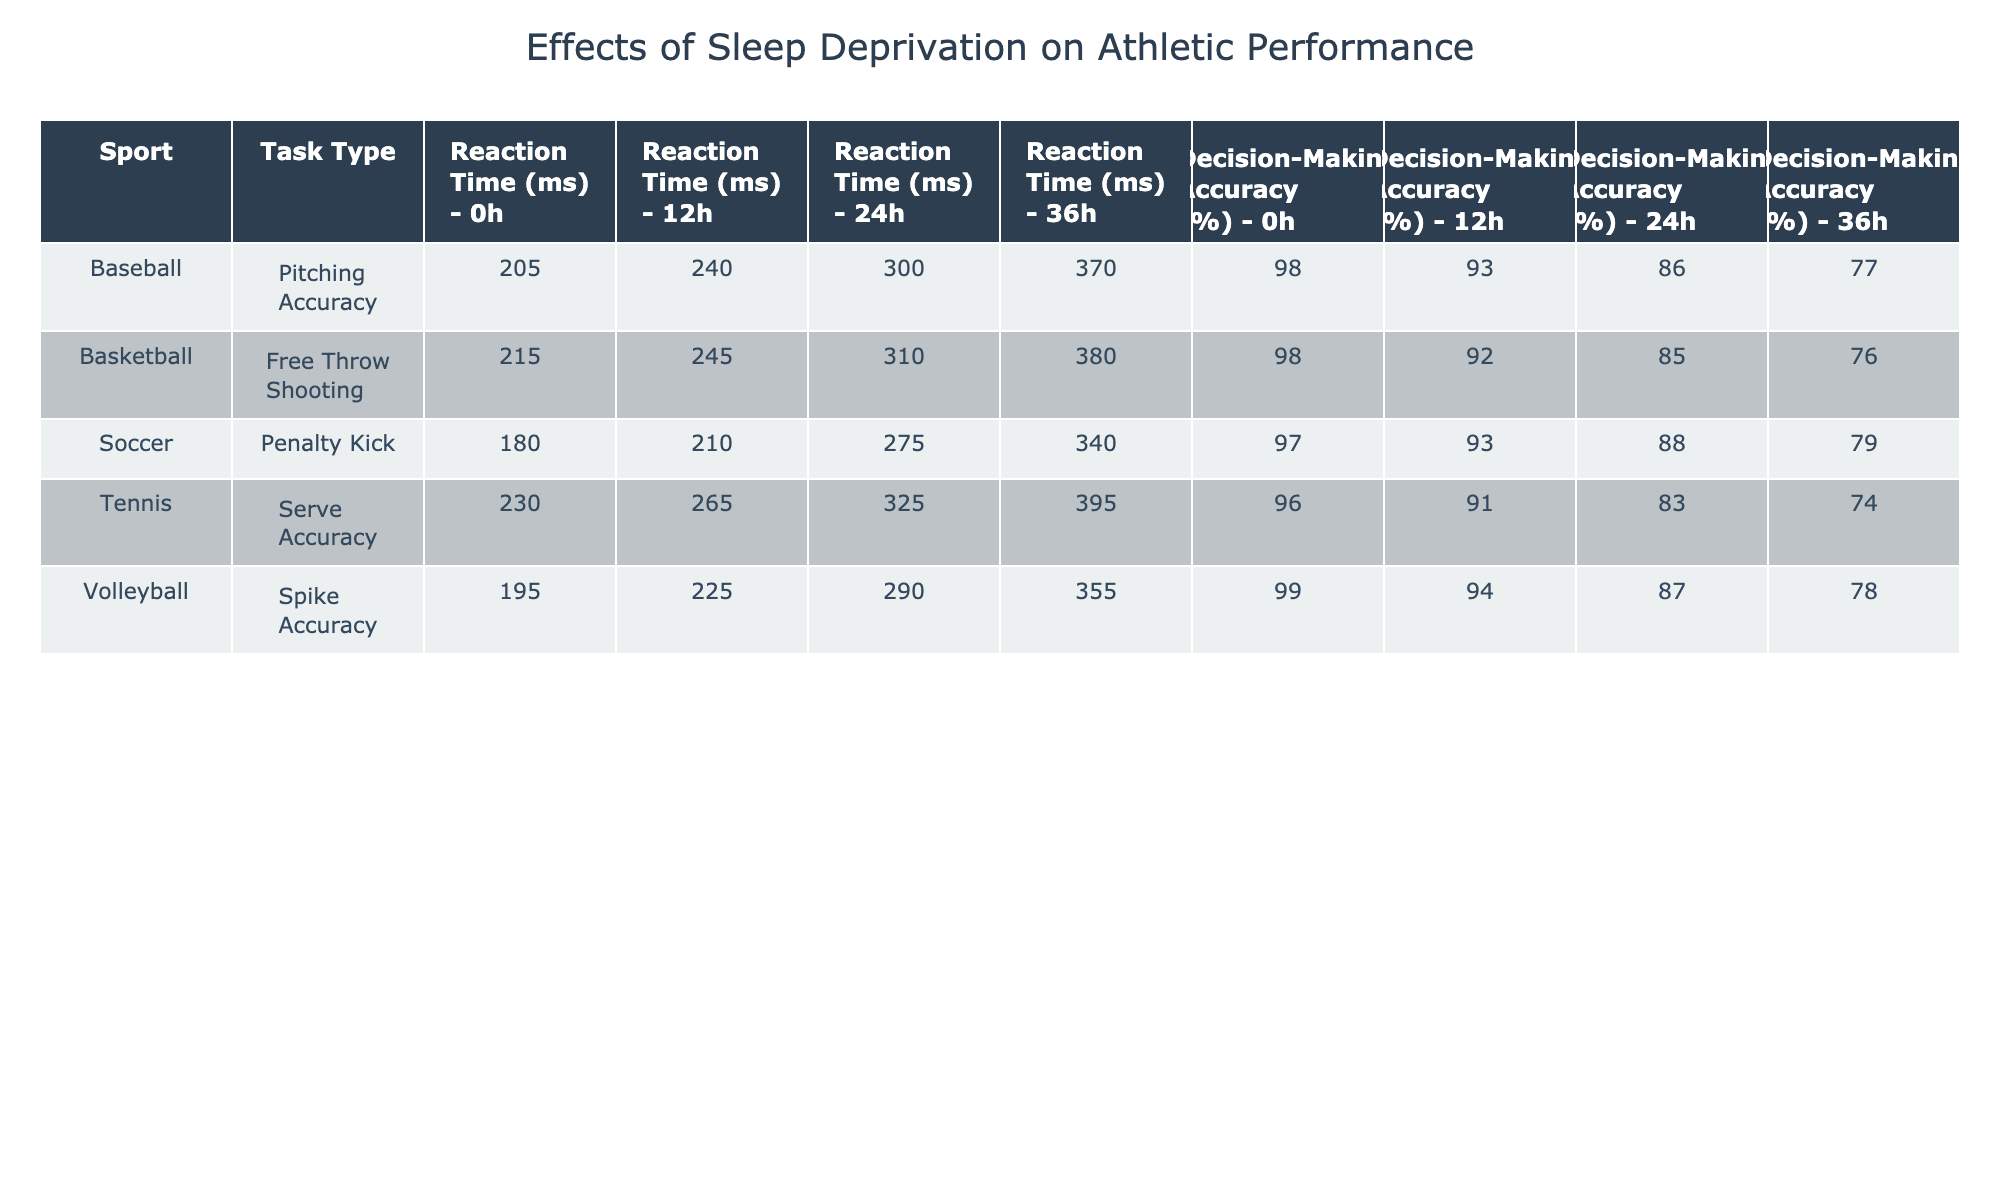What is the reaction time for free throw shooting after 36 hours of sleep deprivation? Looking at the row for Basketball and Free Throw Shooting under the column for 36 hours of sleep deprivation, the reaction time is 380 ms.
Answer: 380 ms What is the decision-making accuracy for penalty kick tasks at 12 hours of sleep deprivation? Referring to the row for Soccer and Penalty Kick under the column for 12 hours of sleep deprivation, the decision-making accuracy is 93%.
Answer: 93% Which sport has the highest decision-making accuracy at 0 hours of sleep deprivation? Checking the 0-hour row for all sports, Volleyball at 0 hours has the highest accuracy at 99%.
Answer: 99% What is the average reaction time for Tennis serve accuracy tasks across all sleep deprivation stages? The reaction times for Tennis serve accuracy tasks are 230 ms, 265 ms, 325 ms, and 395 ms. The average is (230 + 265 + 325 + 395) / 4 = 303.75 ms.
Answer: 303.75 ms Does reaction time increase or decrease with sleep deprivation in all sports? Observing the table, reaction time increases as sleep deprivation increases for all sports and task types listed.
Answer: Yes What was the change in decision-making accuracy from 0 to 36 hours of sleep deprivation for Basketball free throw shooting? The decision-making accuracy decreased from 98% at 0 hours to 76% at 36 hours of sleep deprivation, which is a change of 22%.
Answer: 22% What is the sum of decision-making accuracies for all sports at 24 hours of sleep deprivation? The accuracies at 24 hours are Basketball 85%, Soccer 88%, Tennis 83%, Volleyball 87%, and Baseball 86%. The sum is 85 + 88 + 83 + 87 + 86 = 429%.
Answer: 429% Which sport and task type had the lowest decision-making accuracy and what was it? The lowest decision-making accuracy can be found in the row for Tennis and Serve Accuracy at 36 hours of sleep deprivation at 74%.
Answer: Tennis Serve Accuracy, 74% How does the reaction time for Soccer penalty kicks at 0 hours of sleep deprivation compare to that at 36 hours? Reaction time for Soccer penalty kicks is 180 ms at 0 hours and 340 ms at 36 hours of sleep deprivation, indicating an increase of 160 ms.
Answer: Increased by 160 ms Is there a sport where decision-making accuracy at 12 hours of sleep deprivation is lower than 90%? Looking at the data for 12 hours, Tennis at 91% and Volleyball at 94% are above 90%. Therefore, no sport's accuracy at 12 hours is lower than 90%.
Answer: No 